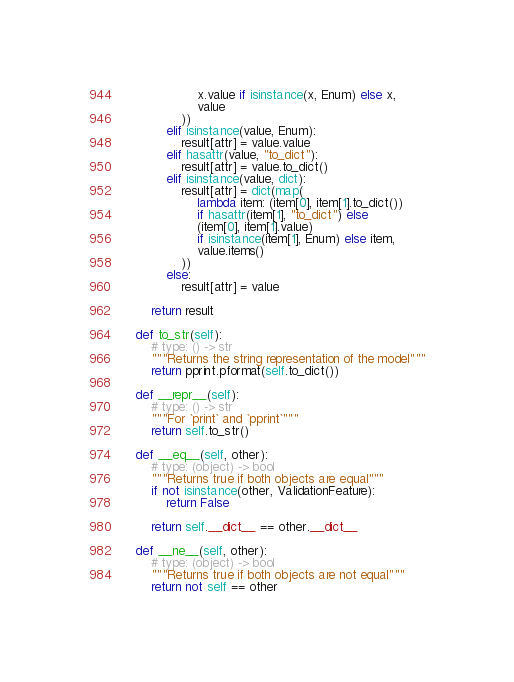<code> <loc_0><loc_0><loc_500><loc_500><_Python_>                    x.value if isinstance(x, Enum) else x,
                    value
                ))
            elif isinstance(value, Enum):
                result[attr] = value.value
            elif hasattr(value, "to_dict"):
                result[attr] = value.to_dict()
            elif isinstance(value, dict):
                result[attr] = dict(map(
                    lambda item: (item[0], item[1].to_dict())
                    if hasattr(item[1], "to_dict") else
                    (item[0], item[1].value)
                    if isinstance(item[1], Enum) else item,
                    value.items()
                ))
            else:
                result[attr] = value

        return result

    def to_str(self):
        # type: () -> str
        """Returns the string representation of the model"""
        return pprint.pformat(self.to_dict())

    def __repr__(self):
        # type: () -> str
        """For `print` and `pprint`"""
        return self.to_str()

    def __eq__(self, other):
        # type: (object) -> bool
        """Returns true if both objects are equal"""
        if not isinstance(other, ValidationFeature):
            return False

        return self.__dict__ == other.__dict__

    def __ne__(self, other):
        # type: (object) -> bool
        """Returns true if both objects are not equal"""
        return not self == other
</code> 